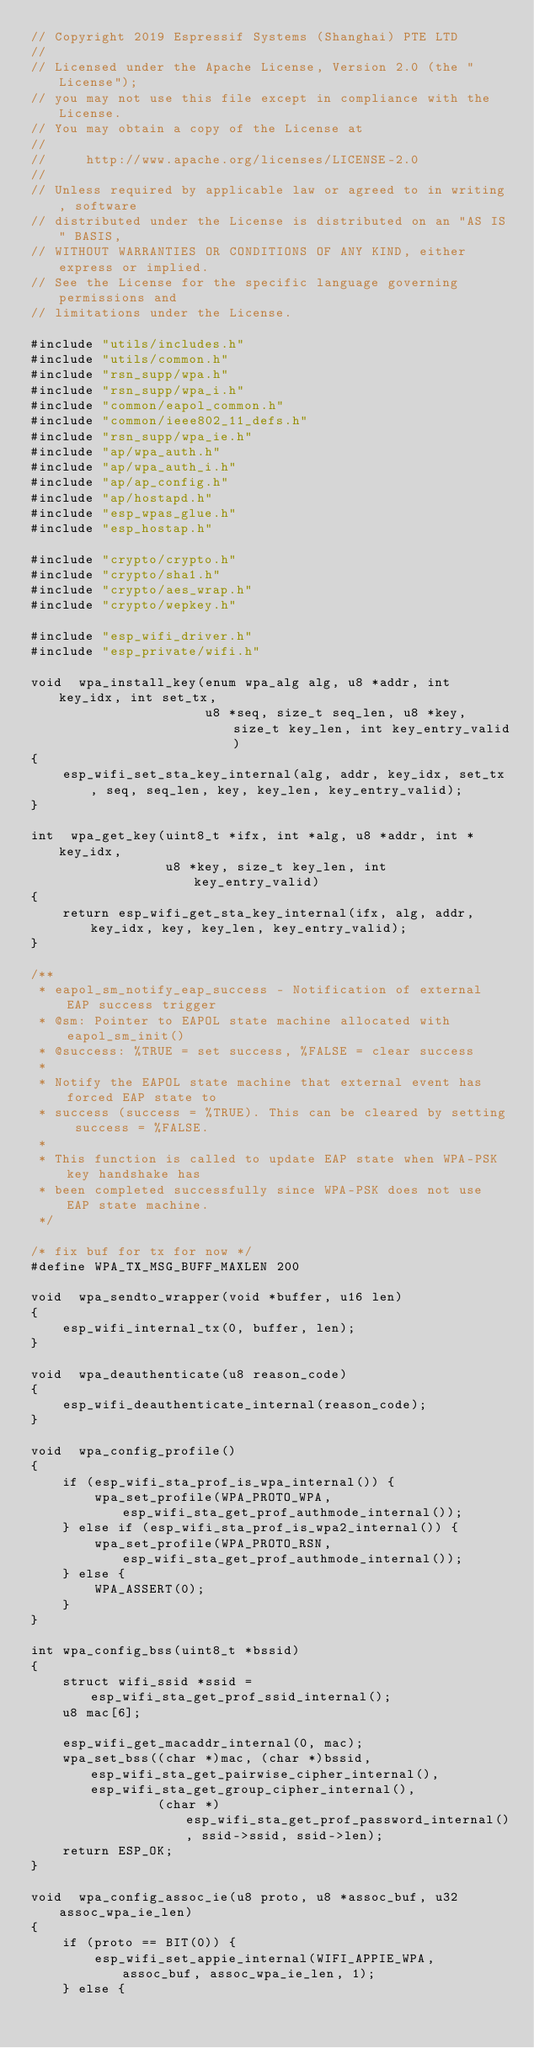Convert code to text. <code><loc_0><loc_0><loc_500><loc_500><_C_>// Copyright 2019 Espressif Systems (Shanghai) PTE LTD
//
// Licensed under the Apache License, Version 2.0 (the "License");
// you may not use this file except in compliance with the License.
// You may obtain a copy of the License at
//
//     http://www.apache.org/licenses/LICENSE-2.0
//
// Unless required by applicable law or agreed to in writing, software
// distributed under the License is distributed on an "AS IS" BASIS,
// WITHOUT WARRANTIES OR CONDITIONS OF ANY KIND, either express or implied.
// See the License for the specific language governing permissions and
// limitations under the License.

#include "utils/includes.h"
#include "utils/common.h"
#include "rsn_supp/wpa.h"
#include "rsn_supp/wpa_i.h"
#include "common/eapol_common.h"
#include "common/ieee802_11_defs.h"
#include "rsn_supp/wpa_ie.h"
#include "ap/wpa_auth.h"
#include "ap/wpa_auth_i.h"
#include "ap/ap_config.h"
#include "ap/hostapd.h"
#include "esp_wpas_glue.h"
#include "esp_hostap.h"

#include "crypto/crypto.h"
#include "crypto/sha1.h"
#include "crypto/aes_wrap.h"
#include "crypto/wepkey.h"

#include "esp_wifi_driver.h"
#include "esp_private/wifi.h"

void  wpa_install_key(enum wpa_alg alg, u8 *addr, int key_idx, int set_tx,
                      u8 *seq, size_t seq_len, u8 *key, size_t key_len, int key_entry_valid)
{
    esp_wifi_set_sta_key_internal(alg, addr, key_idx, set_tx, seq, seq_len, key, key_len, key_entry_valid);
}

int  wpa_get_key(uint8_t *ifx, int *alg, u8 *addr, int *key_idx,
                 u8 *key, size_t key_len, int key_entry_valid)
{
    return esp_wifi_get_sta_key_internal(ifx, alg, addr, key_idx, key, key_len, key_entry_valid);
}

/**
 * eapol_sm_notify_eap_success - Notification of external EAP success trigger
 * @sm: Pointer to EAPOL state machine allocated with eapol_sm_init()
 * @success: %TRUE = set success, %FALSE = clear success
 *
 * Notify the EAPOL state machine that external event has forced EAP state to
 * success (success = %TRUE). This can be cleared by setting success = %FALSE.
 *
 * This function is called to update EAP state when WPA-PSK key handshake has
 * been completed successfully since WPA-PSK does not use EAP state machine.
 */

/* fix buf for tx for now */
#define WPA_TX_MSG_BUFF_MAXLEN 200

void  wpa_sendto_wrapper(void *buffer, u16 len)
{
    esp_wifi_internal_tx(0, buffer, len);
}

void  wpa_deauthenticate(u8 reason_code)
{
    esp_wifi_deauthenticate_internal(reason_code);
}

void  wpa_config_profile()
{
    if (esp_wifi_sta_prof_is_wpa_internal()) {
        wpa_set_profile(WPA_PROTO_WPA, esp_wifi_sta_get_prof_authmode_internal());
    } else if (esp_wifi_sta_prof_is_wpa2_internal()) {
        wpa_set_profile(WPA_PROTO_RSN, esp_wifi_sta_get_prof_authmode_internal());
    } else {
        WPA_ASSERT(0);
    }
}

int wpa_config_bss(uint8_t *bssid)
{
    struct wifi_ssid *ssid = esp_wifi_sta_get_prof_ssid_internal();
    u8 mac[6];

    esp_wifi_get_macaddr_internal(0, mac);
    wpa_set_bss((char *)mac, (char *)bssid, esp_wifi_sta_get_pairwise_cipher_internal(), esp_wifi_sta_get_group_cipher_internal(),
                (char *)esp_wifi_sta_get_prof_password_internal(), ssid->ssid, ssid->len);
    return ESP_OK;
}

void  wpa_config_assoc_ie(u8 proto, u8 *assoc_buf, u32 assoc_wpa_ie_len)
{
    if (proto == BIT(0)) {
        esp_wifi_set_appie_internal(WIFI_APPIE_WPA, assoc_buf, assoc_wpa_ie_len, 1);
    } else {</code> 